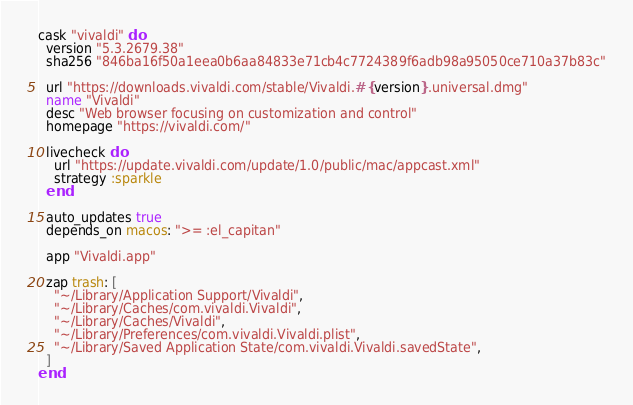Convert code to text. <code><loc_0><loc_0><loc_500><loc_500><_Ruby_>cask "vivaldi" do
  version "5.3.2679.38"
  sha256 "846ba16f50a1eea0b6aa84833e71cb4c7724389f6adb98a95050ce710a37b83c"

  url "https://downloads.vivaldi.com/stable/Vivaldi.#{version}.universal.dmg"
  name "Vivaldi"
  desc "Web browser focusing on customization and control"
  homepage "https://vivaldi.com/"

  livecheck do
    url "https://update.vivaldi.com/update/1.0/public/mac/appcast.xml"
    strategy :sparkle
  end

  auto_updates true
  depends_on macos: ">= :el_capitan"

  app "Vivaldi.app"

  zap trash: [
    "~/Library/Application Support/Vivaldi",
    "~/Library/Caches/com.vivaldi.Vivaldi",
    "~/Library/Caches/Vivaldi",
    "~/Library/Preferences/com.vivaldi.Vivaldi.plist",
    "~/Library/Saved Application State/com.vivaldi.Vivaldi.savedState",
  ]
end
</code> 